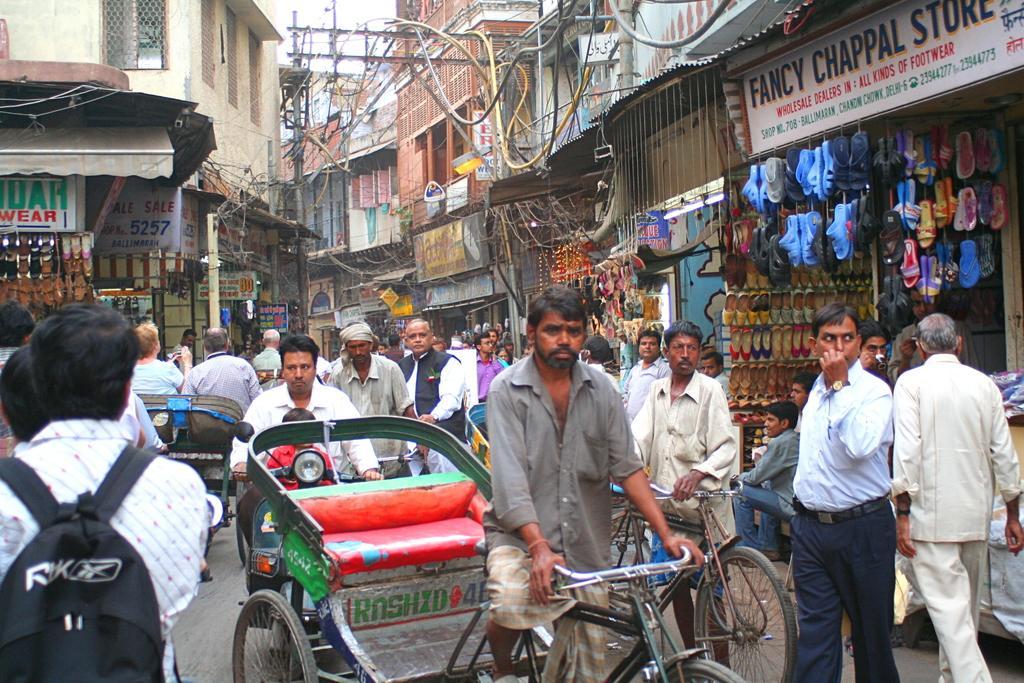Describe this image in one or two sentences. In this image I see number of people in which I see this man is on the cycle and this man is on the scooter and I see 2 more cycles over here and I see the buildings and I can also shops in which there are footwear and I see the boards on which there are words and numbers written and I see the pipes on the iron rods and I see the sky. 